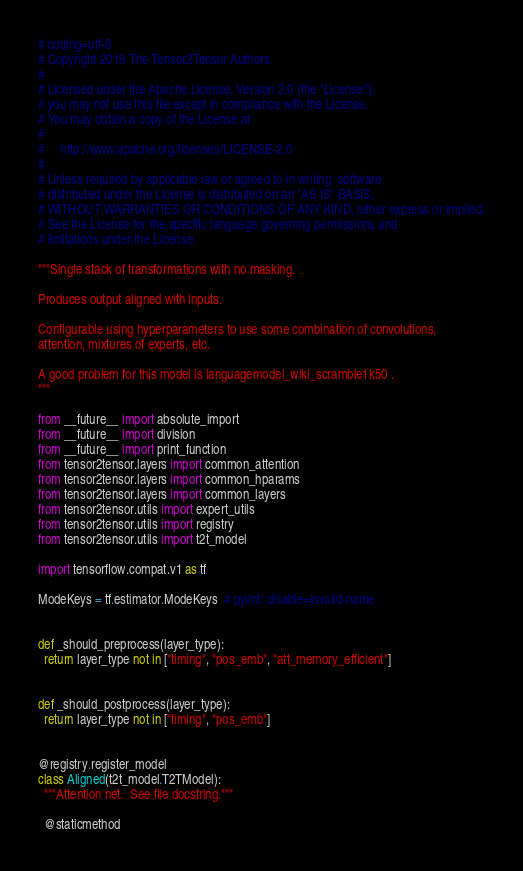<code> <loc_0><loc_0><loc_500><loc_500><_Python_># coding=utf-8
# Copyright 2019 The Tensor2Tensor Authors.
#
# Licensed under the Apache License, Version 2.0 (the "License");
# you may not use this file except in compliance with the License.
# You may obtain a copy of the License at
#
#     http://www.apache.org/licenses/LICENSE-2.0
#
# Unless required by applicable law or agreed to in writing, software
# distributed under the License is distributed on an "AS IS" BASIS,
# WITHOUT WARRANTIES OR CONDITIONS OF ANY KIND, either express or implied.
# See the License for the specific language governing permissions and
# limitations under the License.

"""Single stack of transformations with no masking.

Produces output aligned with inputs.

Configurable using hyperparameters to use some combination of convolutions,
attention, mixtures of experts, etc.

A good problem for this model is languagemodel_wiki_scramble1k50 .
"""

from __future__ import absolute_import
from __future__ import division
from __future__ import print_function
from tensor2tensor.layers import common_attention
from tensor2tensor.layers import common_hparams
from tensor2tensor.layers import common_layers
from tensor2tensor.utils import expert_utils
from tensor2tensor.utils import registry
from tensor2tensor.utils import t2t_model

import tensorflow.compat.v1 as tf

ModeKeys = tf.estimator.ModeKeys  # pylint: disable=invalid-name


def _should_preprocess(layer_type):
  return layer_type not in ["timing", "pos_emb", "att_memory_efficient"]


def _should_postprocess(layer_type):
  return layer_type not in ["timing", "pos_emb"]


@registry.register_model
class Aligned(t2t_model.T2TModel):
  """Attention net.  See file docstring."""

  @staticmethod</code> 